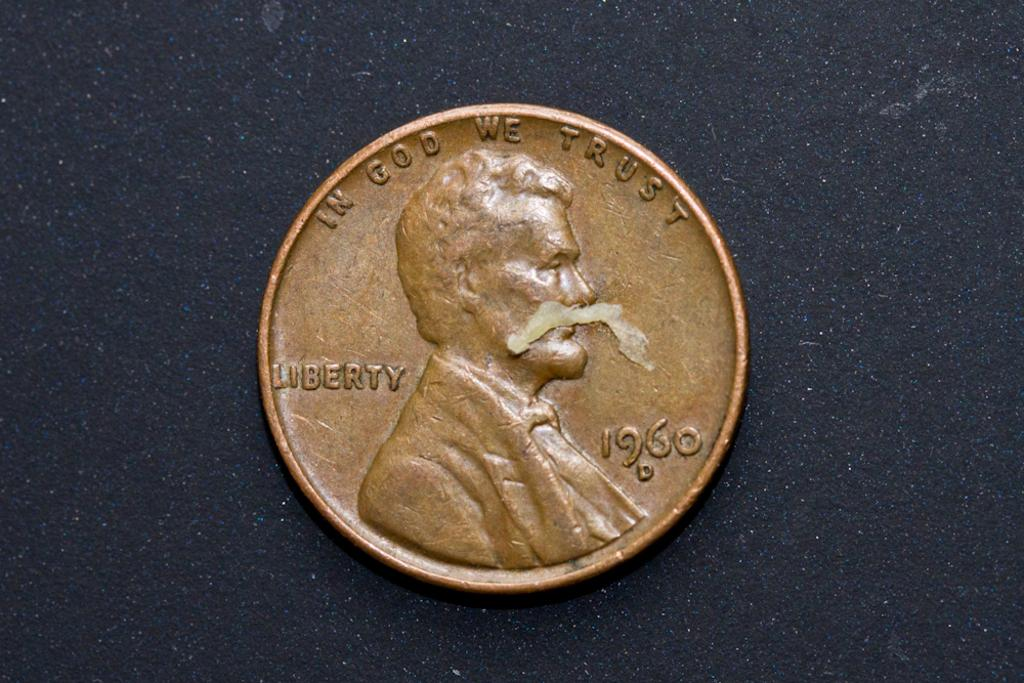<image>
Give a short and clear explanation of the subsequent image. An American copper penny with the words In God We Trust, Liberty written on it along with the date of 1960. 